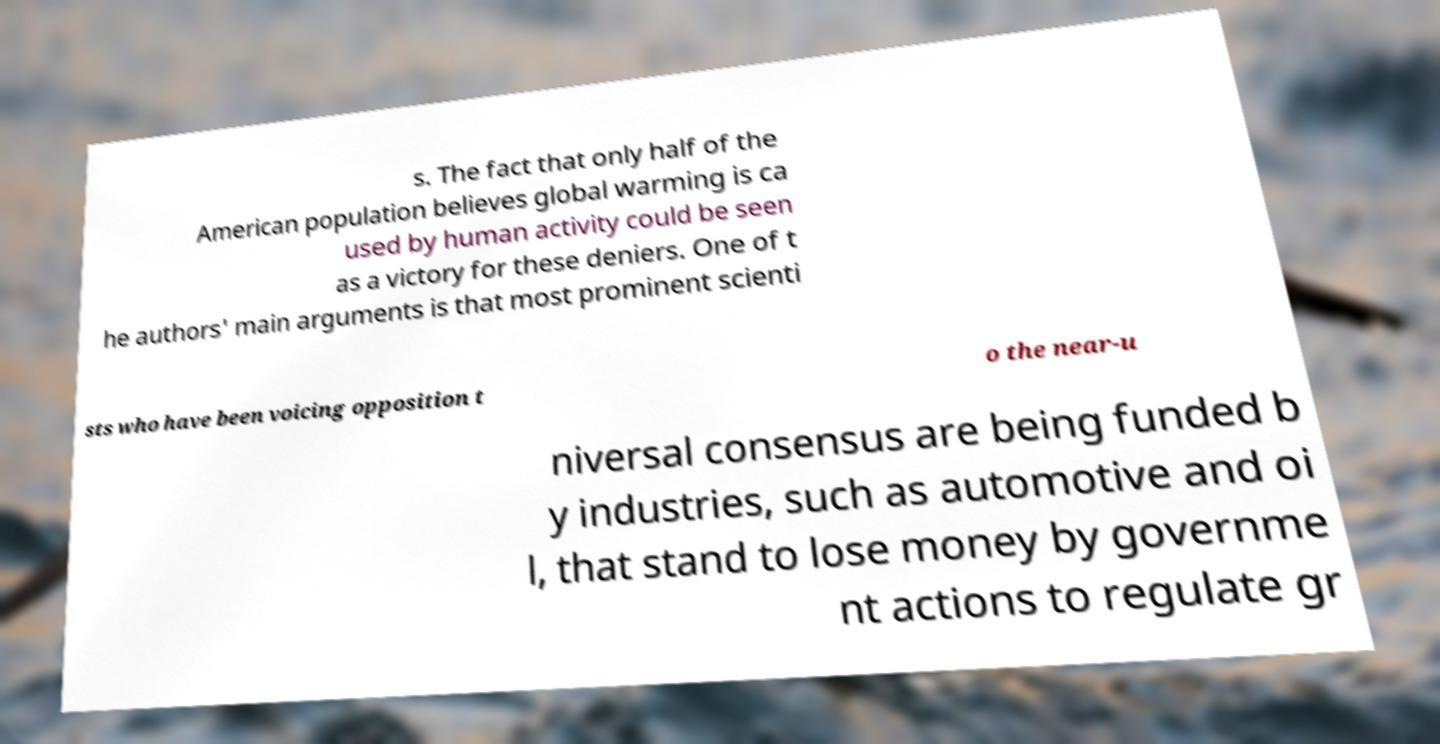I need the written content from this picture converted into text. Can you do that? s. The fact that only half of the American population believes global warming is ca used by human activity could be seen as a victory for these deniers. One of t he authors' main arguments is that most prominent scienti sts who have been voicing opposition t o the near-u niversal consensus are being funded b y industries, such as automotive and oi l, that stand to lose money by governme nt actions to regulate gr 